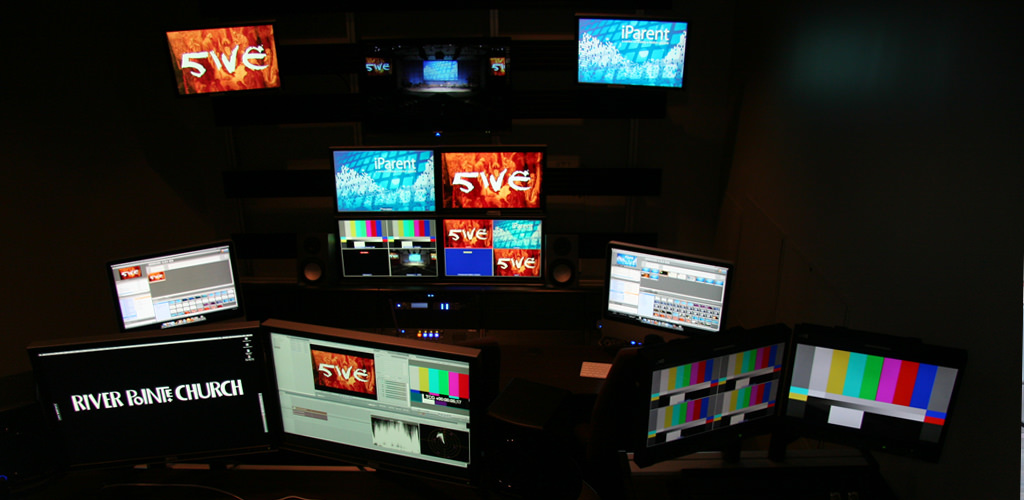How does the layout of the equipment affect the functionality of the room? The layout, with tiered monitors and a central control station, supports efficient workflow management, allowing a single operator or a small team to monitor multiple feeds and control different aspects of production simultaneously, effectively managing complex multimedia outputs. 